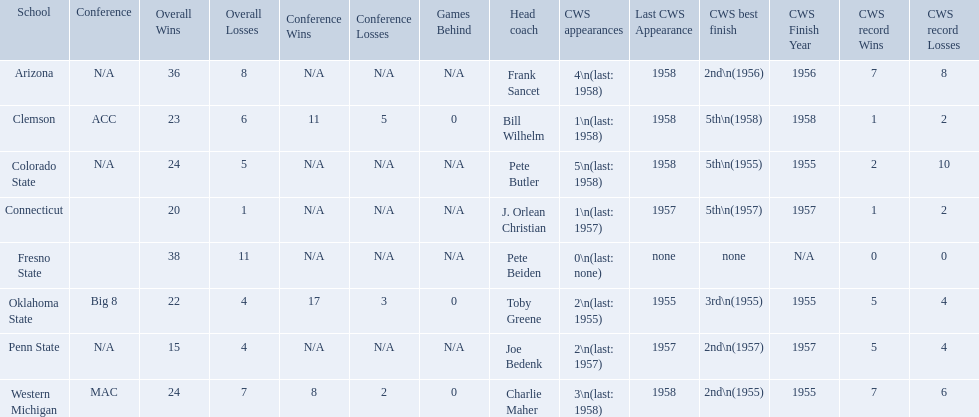What are all the school names? Arizona, Clemson, Colorado State, Connecticut, Fresno State, Oklahoma State, Penn State, Western Michigan. What is the record for each? 36–8 (N/A), 23 –6 (11–5, 0 GB), 24–5 (N/A), 20–1 (N/A), 38–11 (N/A), 22–4 (17–3, 0 GB), 15–4 (N/A), 24–7 (8–2, 0 GB). Which school had the fewest number of wins? Penn State. What are all the schools? Arizona, Clemson, Colorado State, Connecticut, Fresno State, Oklahoma State, Penn State, Western Michigan. Which are clemson and western michigan? Clemson, Western Michigan. Of these, which has more cws appearances? Western Michigan. 